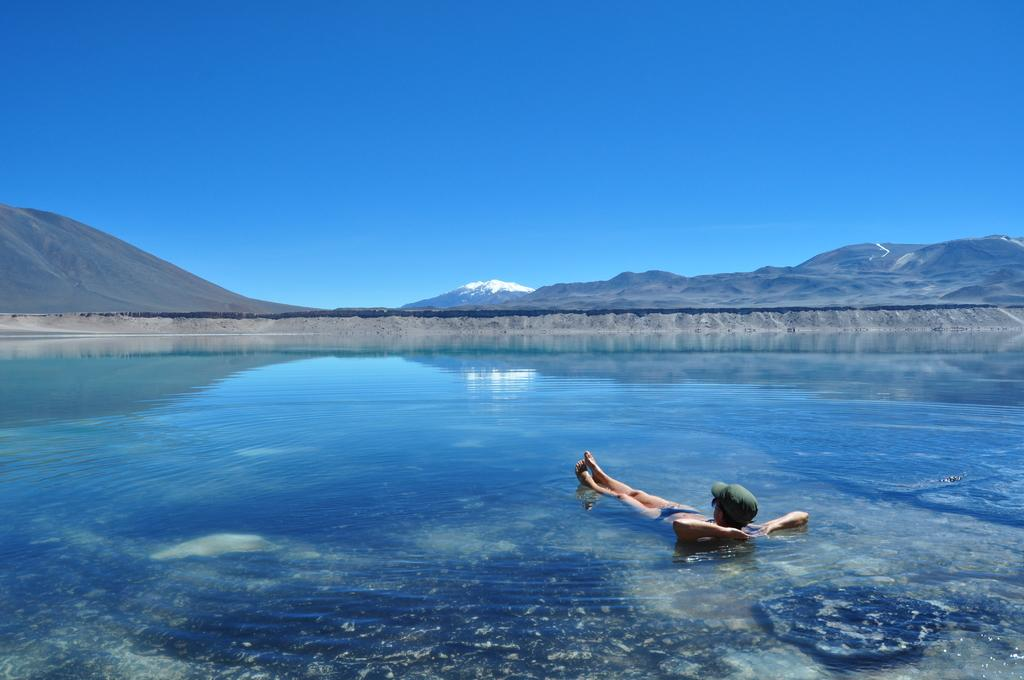What can be seen in the sky in the image? The sky is visible in the image. What type of landforms are present in the image? There are hills and mountains in the image. What body of water is present in the image? There is a river in the image. What is the person in the image doing? There is a person in the water in the image. What type of hand can be seen holding a box in the image? There is no hand or box present in the image. How many yards of fabric are visible in the image? There is no fabric or yard measurement present in the image. 